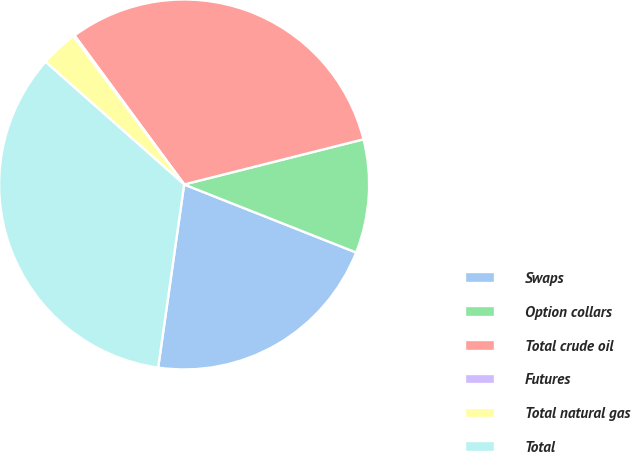Convert chart. <chart><loc_0><loc_0><loc_500><loc_500><pie_chart><fcel>Swaps<fcel>Option collars<fcel>Total crude oil<fcel>Futures<fcel>Total natural gas<fcel>Total<nl><fcel>21.25%<fcel>9.92%<fcel>31.17%<fcel>0.13%<fcel>3.25%<fcel>34.29%<nl></chart> 